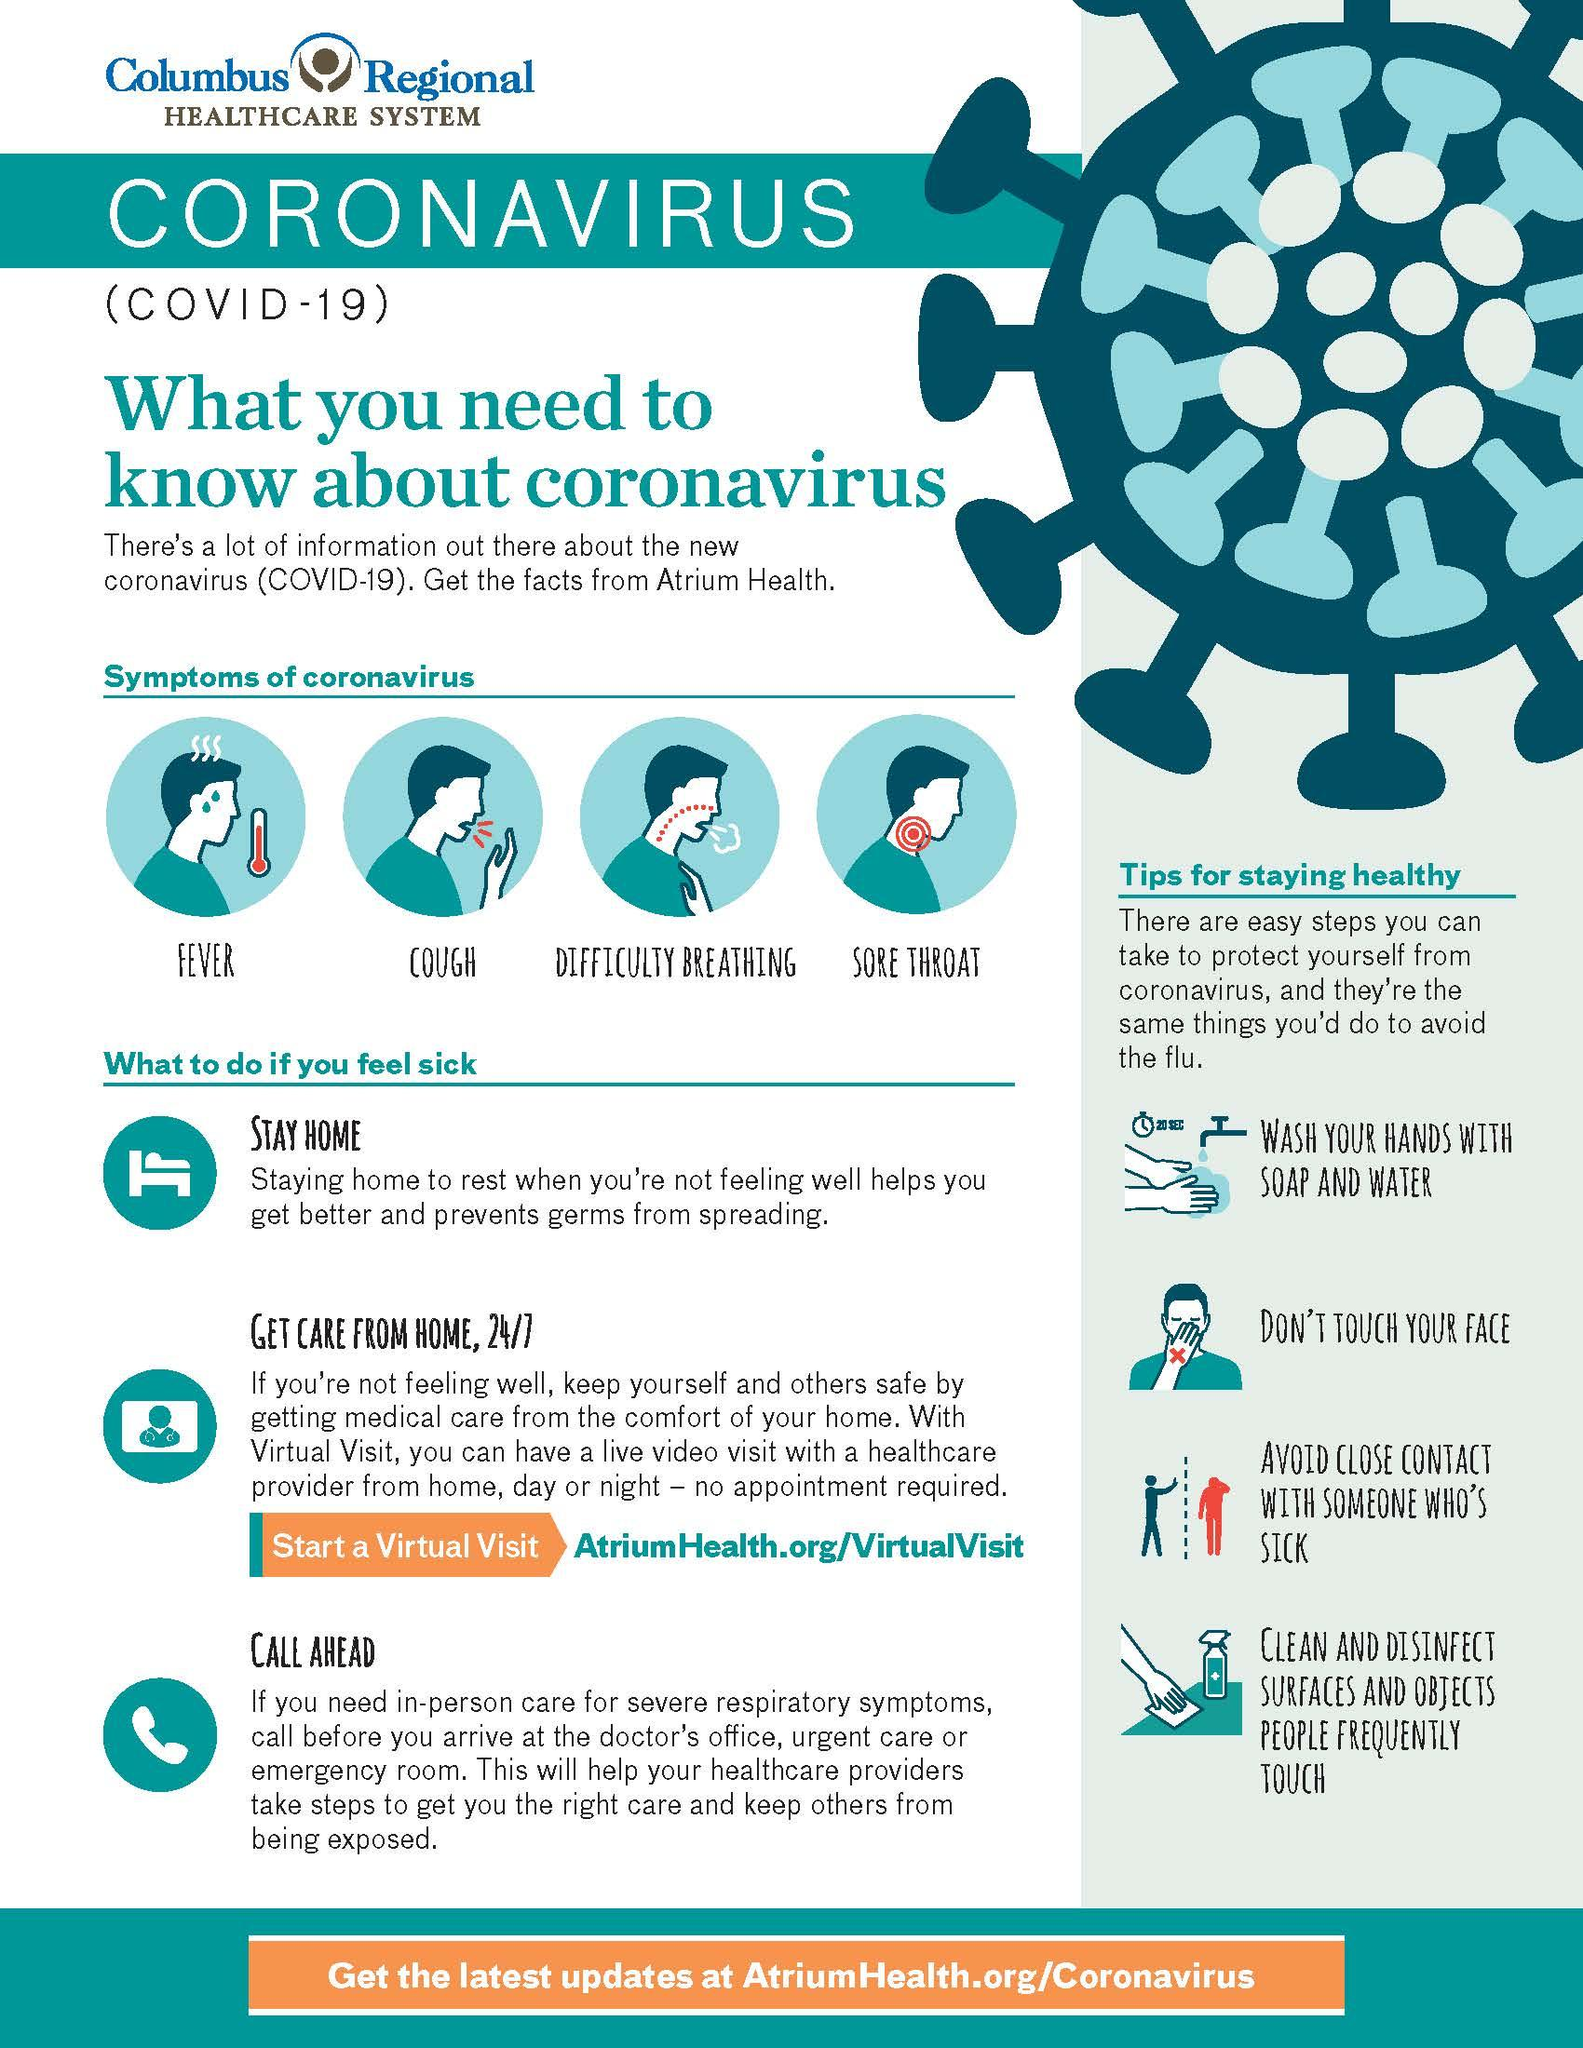Draw attention to some important aspects in this diagram. It is important to avoid touching your face in order to maintain good health. The infographic depicts the fourth symptom of coronavirus as a sore throat. The infographic mentions 4 tips for maintaining health. The second symptom of coronavirus displayed in the infographic is coughing. The infographic illustrates the presence of four symptoms of the coronavirus. 